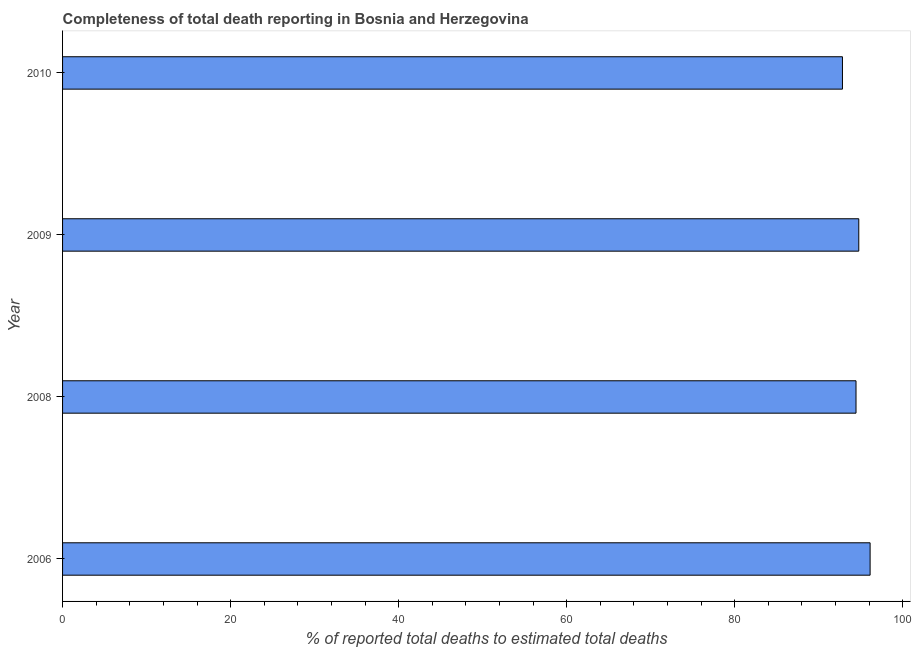What is the title of the graph?
Provide a succinct answer. Completeness of total death reporting in Bosnia and Herzegovina. What is the label or title of the X-axis?
Offer a very short reply. % of reported total deaths to estimated total deaths. What is the completeness of total death reports in 2006?
Your response must be concise. 96.11. Across all years, what is the maximum completeness of total death reports?
Your answer should be very brief. 96.11. Across all years, what is the minimum completeness of total death reports?
Ensure brevity in your answer.  92.82. In which year was the completeness of total death reports maximum?
Ensure brevity in your answer.  2006. In which year was the completeness of total death reports minimum?
Offer a terse response. 2010. What is the sum of the completeness of total death reports?
Your answer should be compact. 378.13. What is the difference between the completeness of total death reports in 2008 and 2009?
Provide a succinct answer. -0.33. What is the average completeness of total death reports per year?
Give a very brief answer. 94.53. What is the median completeness of total death reports?
Your answer should be compact. 94.6. In how many years, is the completeness of total death reports greater than 4 %?
Give a very brief answer. 4. Do a majority of the years between 2008 and 2009 (inclusive) have completeness of total death reports greater than 32 %?
Your answer should be very brief. Yes. Is the difference between the completeness of total death reports in 2008 and 2009 greater than the difference between any two years?
Provide a succinct answer. No. What is the difference between the highest and the second highest completeness of total death reports?
Provide a succinct answer. 1.35. What is the difference between the highest and the lowest completeness of total death reports?
Offer a terse response. 3.29. How many bars are there?
Ensure brevity in your answer.  4. What is the difference between two consecutive major ticks on the X-axis?
Provide a short and direct response. 20. What is the % of reported total deaths to estimated total deaths in 2006?
Keep it short and to the point. 96.11. What is the % of reported total deaths to estimated total deaths in 2008?
Provide a short and direct response. 94.43. What is the % of reported total deaths to estimated total deaths of 2009?
Offer a terse response. 94.76. What is the % of reported total deaths to estimated total deaths in 2010?
Your answer should be very brief. 92.82. What is the difference between the % of reported total deaths to estimated total deaths in 2006 and 2008?
Ensure brevity in your answer.  1.68. What is the difference between the % of reported total deaths to estimated total deaths in 2006 and 2009?
Ensure brevity in your answer.  1.35. What is the difference between the % of reported total deaths to estimated total deaths in 2006 and 2010?
Your answer should be compact. 3.29. What is the difference between the % of reported total deaths to estimated total deaths in 2008 and 2009?
Keep it short and to the point. -0.33. What is the difference between the % of reported total deaths to estimated total deaths in 2008 and 2010?
Your answer should be very brief. 1.61. What is the difference between the % of reported total deaths to estimated total deaths in 2009 and 2010?
Ensure brevity in your answer.  1.94. What is the ratio of the % of reported total deaths to estimated total deaths in 2006 to that in 2009?
Ensure brevity in your answer.  1.01. What is the ratio of the % of reported total deaths to estimated total deaths in 2006 to that in 2010?
Your answer should be compact. 1.03. What is the ratio of the % of reported total deaths to estimated total deaths in 2008 to that in 2010?
Offer a very short reply. 1.02. 